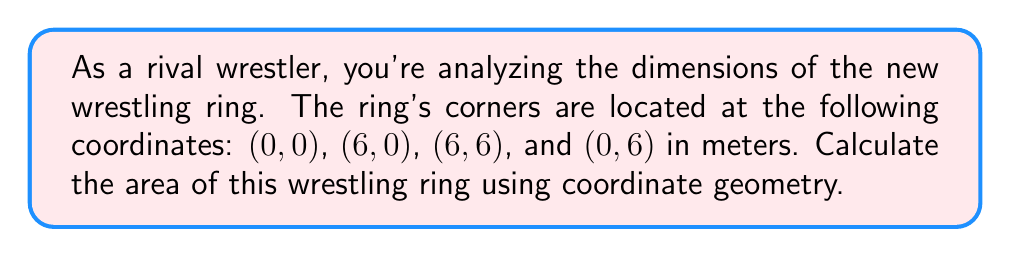Provide a solution to this math problem. Let's approach this step-by-step:

1) The wrestling ring forms a rectangle in the coordinate plane. We can calculate its area by finding the length and width.

2) To find the length:
   - x-coordinate of the right side: 6
   - x-coordinate of the left side: 0
   Length = 6 - 0 = 6 meters

3) To find the width:
   - y-coordinate of the top side: 6
   - y-coordinate of the bottom side: 0
   Width = 6 - 0 = 6 meters

4) The area of a rectangle is given by the formula:
   $$A = l \times w$$
   where $A$ is the area, $l$ is the length, and $w$ is the width.

5) Substituting our values:
   $$A = 6 \times 6 = 36$$

6) Therefore, the area of the wrestling ring is 36 square meters.

[asy]
unitsize(1cm);
draw((0,0)--(6,0)--(6,6)--(0,6)--cycle);
label("(0,0)", (0,0), SW);
label("(6,0)", (6,0), SE);
label("(6,6)", (6,6), NE);
label("(0,6)", (0,6), NW);
label("6m", (3,0), S);
label("6m", (6,3), E);
[/asy]
Answer: 36 m² 